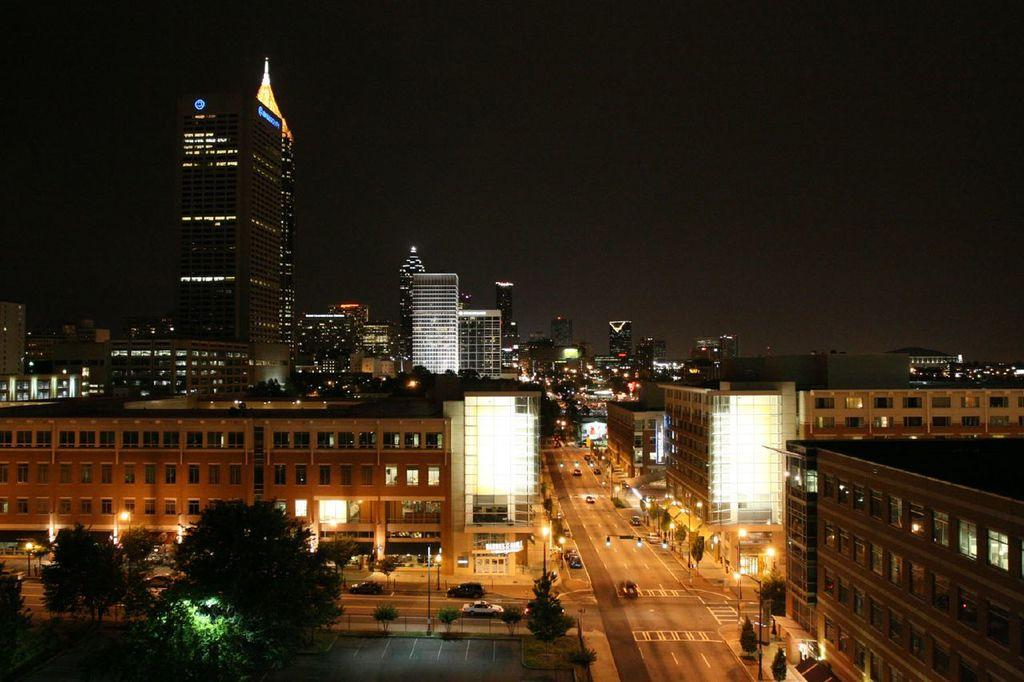What type of structures can be seen in the image? There are buildings in the image. What feature of the buildings is visible in the image? There are windows visible in the image. What can be seen illuminating the scene in the image? There are lights in the image. What mode of transportation can be seen on the road in the image? There are vehicles on the road in the image. What type of vegetation is present in the image? There are trees in the image. What part of the natural environment is visible in the image? The sky is visible in the image. Can you tell me how many pets are visible in the image? There are no pets present in the image; it features buildings, windows, lights, vehicles, trees, and the sky. Are there any kittens visible in the image? There are no kittens present in the image. 